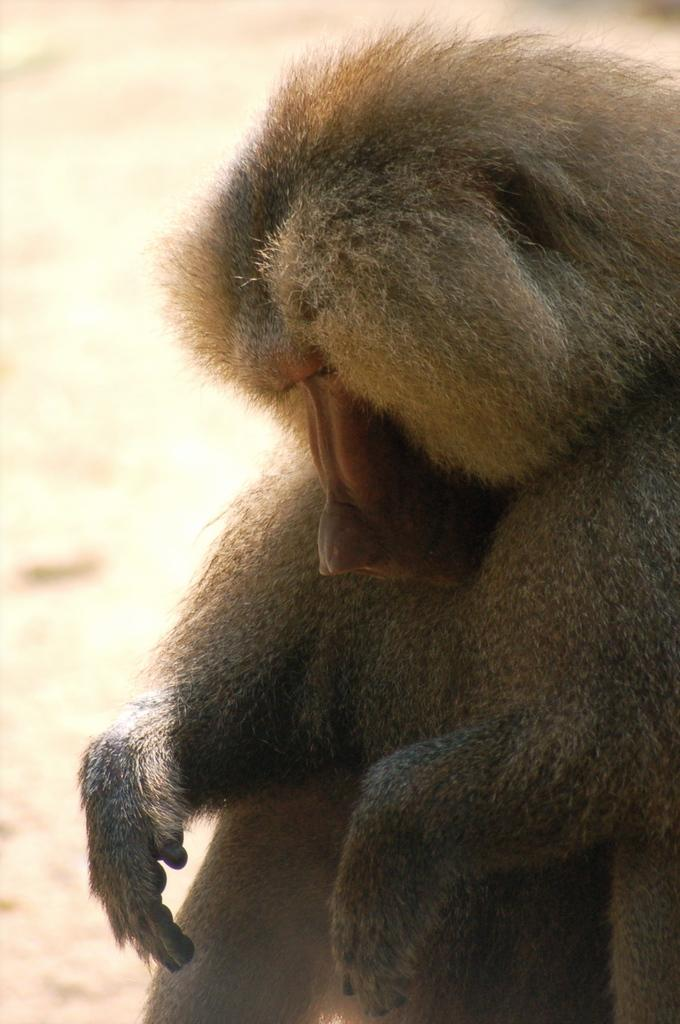What animal is in the image? There is an orangutan in the image. Where is the orangutan located? The orangutan is sitting on the road. What is the orangutan's facial expression? The orangutan's eyes are closed, and its head is bent. What type of vessel is the orangutan using to travel on the earth in the image? There is no vessel present in the image, and the orangutan is sitting on the road, not traveling on the earth. What type of trousers is the orangutan wearing in the image? Orangutans do not wear trousers, as they are animals and not humans. 